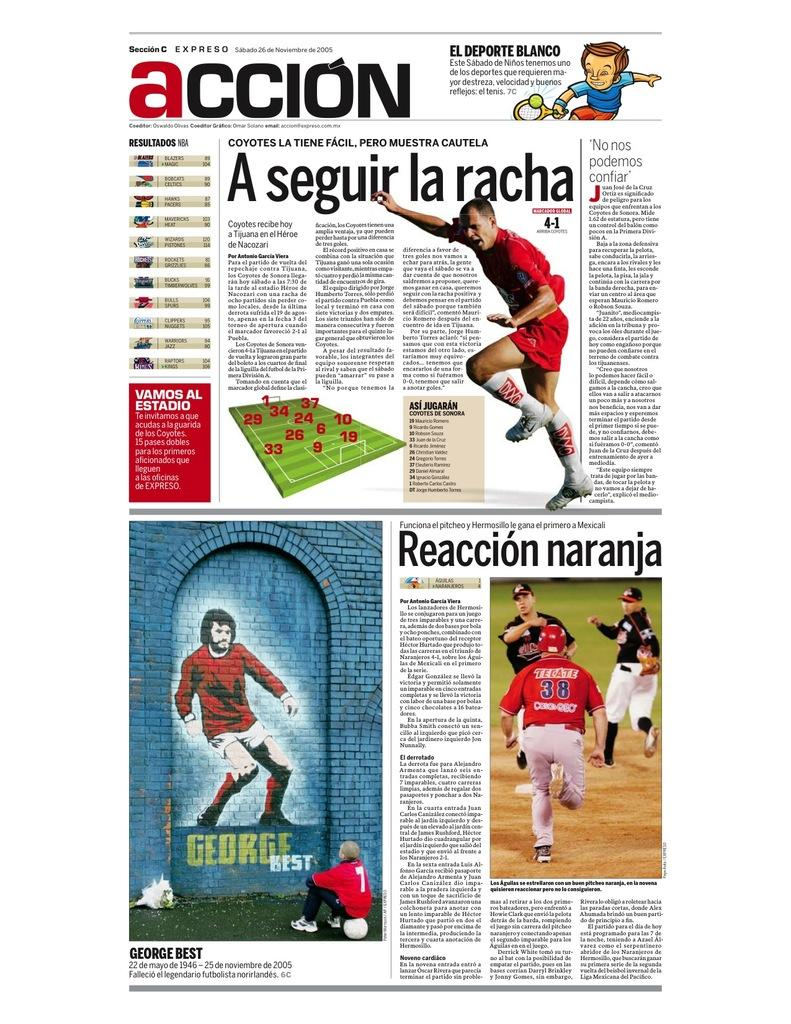Provide a one-sentence caption for the provided image. A foreign magazine features pictures of an unknown footballer, a baseball player and George Best. 